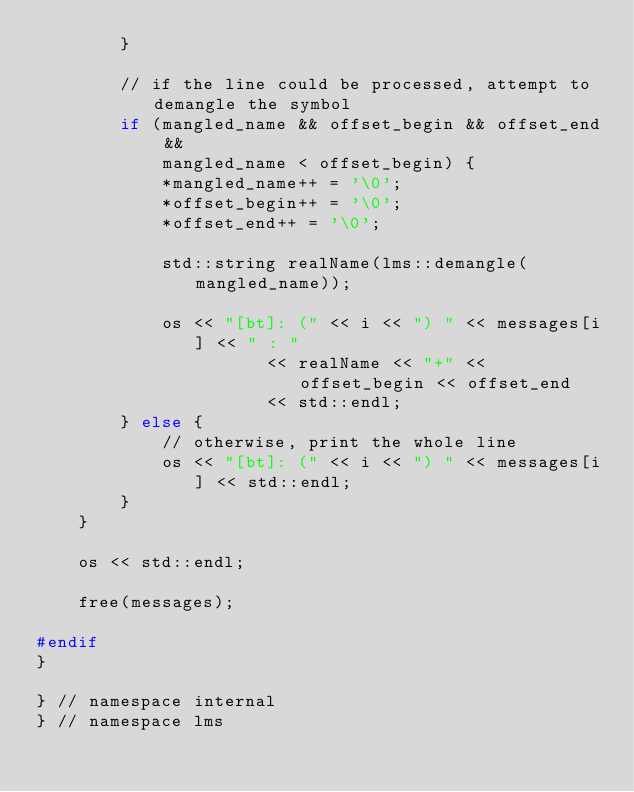<code> <loc_0><loc_0><loc_500><loc_500><_C++_>        }

        // if the line could be processed, attempt to demangle the symbol
        if (mangled_name && offset_begin && offset_end &&
            mangled_name < offset_begin) {
            *mangled_name++ = '\0';
            *offset_begin++ = '\0';
            *offset_end++ = '\0';

            std::string realName(lms::demangle(mangled_name));

            os << "[bt]: (" << i << ") " << messages[i] << " : "
                      << realName << "+" << offset_begin << offset_end
                      << std::endl;
        } else {
            // otherwise, print the whole line
            os << "[bt]: (" << i << ") " << messages[i] << std::endl;
        }
    }

    os << std::endl;

    free(messages);

#endif
}

} // namespace internal
} // namespace lms
</code> 